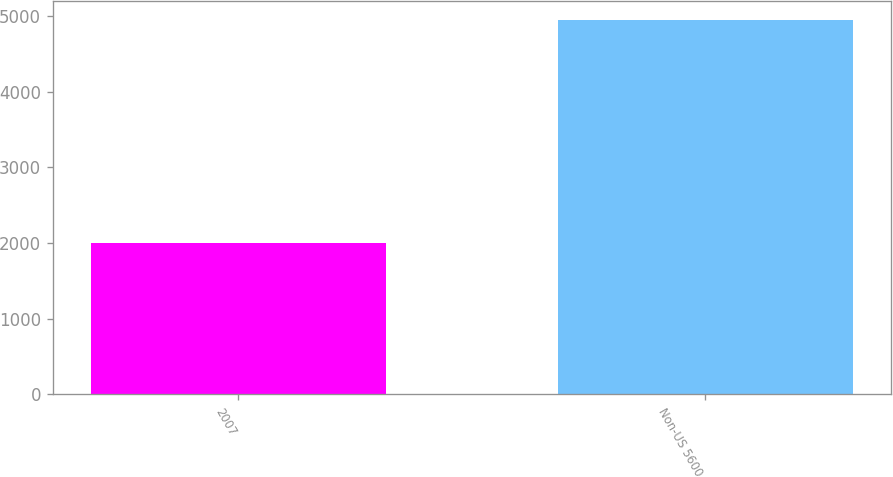<chart> <loc_0><loc_0><loc_500><loc_500><bar_chart><fcel>2007<fcel>Non-US 5600<nl><fcel>2005<fcel>4949<nl></chart> 